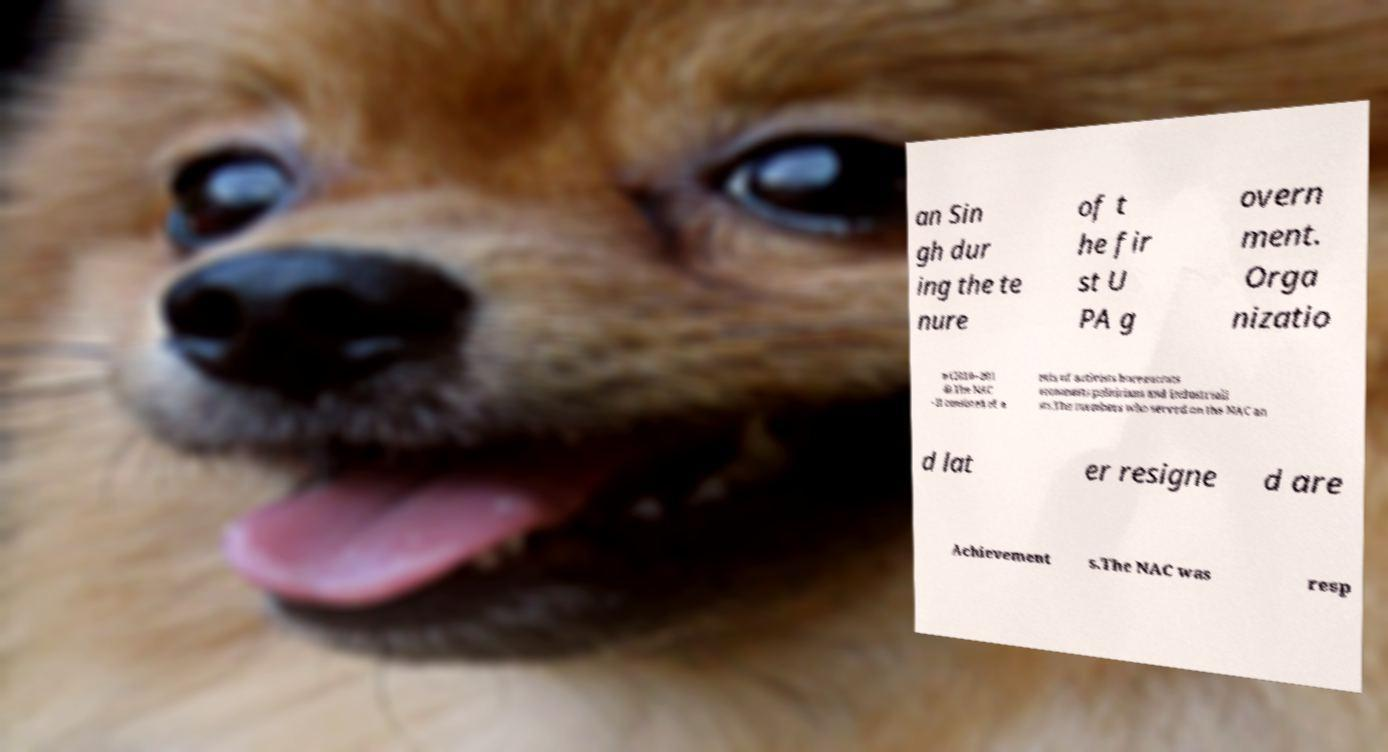What messages or text are displayed in this image? I need them in a readable, typed format. an Sin gh dur ing the te nure of t he fir st U PA g overn ment. Orga nizatio n (2010–201 4).The NAC - II consisted of a mix of activists bureaucrats economists politicians and industriali sts.The members who served on the NAC an d lat er resigne d are Achievement s.The NAC was resp 